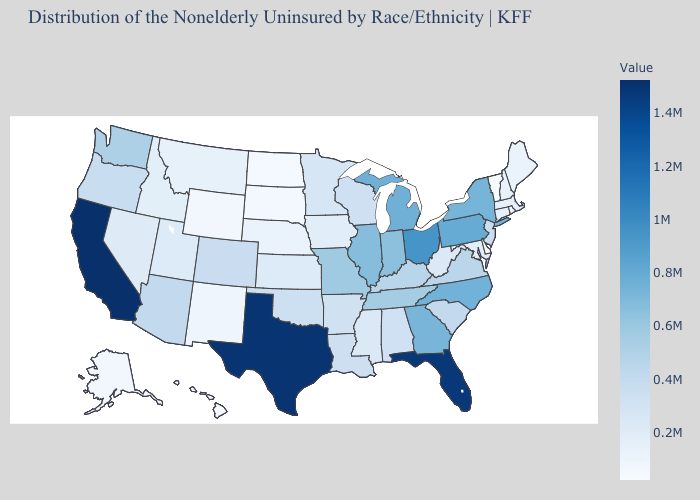Which states hav the highest value in the South?
Give a very brief answer. Texas. Does Delaware have the lowest value in the USA?
Short answer required. No. Does South Carolina have the lowest value in the South?
Give a very brief answer. No. Does Missouri have the highest value in the USA?
Concise answer only. No. Does South Carolina have a higher value than Rhode Island?
Answer briefly. Yes. Is the legend a continuous bar?
Answer briefly. Yes. Which states hav the highest value in the Northeast?
Quick response, please. Pennsylvania. 